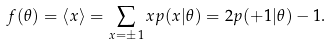Convert formula to latex. <formula><loc_0><loc_0><loc_500><loc_500>f ( \theta ) = \langle x \rangle = \sum _ { x = \pm 1 } x p ( x | \theta ) = 2 p ( + 1 | \theta ) - 1 .</formula> 